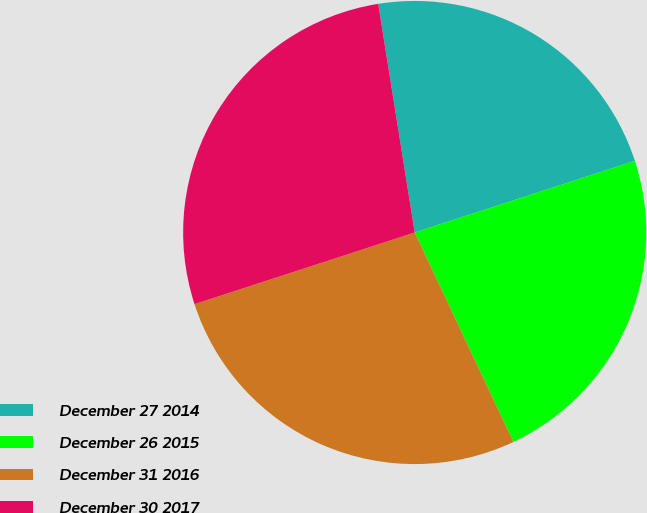Convert chart to OTSL. <chart><loc_0><loc_0><loc_500><loc_500><pie_chart><fcel>December 27 2014<fcel>December 26 2015<fcel>December 31 2016<fcel>December 30 2017<nl><fcel>22.51%<fcel>23.0%<fcel>27.0%<fcel>27.49%<nl></chart> 